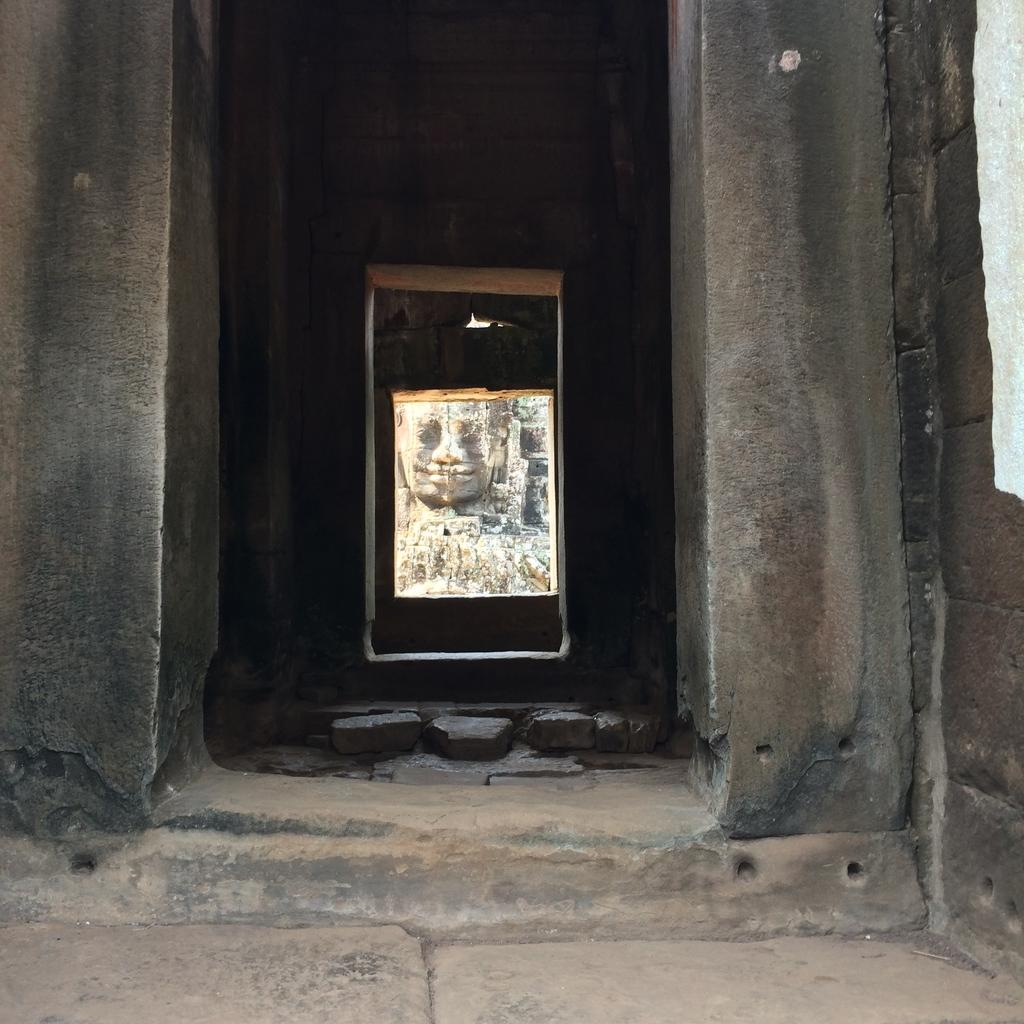What type of structure is present in the image? There is a building in the image. What natural or man-made feature can be seen in the image? The image contains a channel. What artistic element is visible in the background of the image? There is a sculpture visible in the background of the image. What type of prose is being recited by the pets in the image? There are no pets present in the image, and therefore no prose is being recited. 